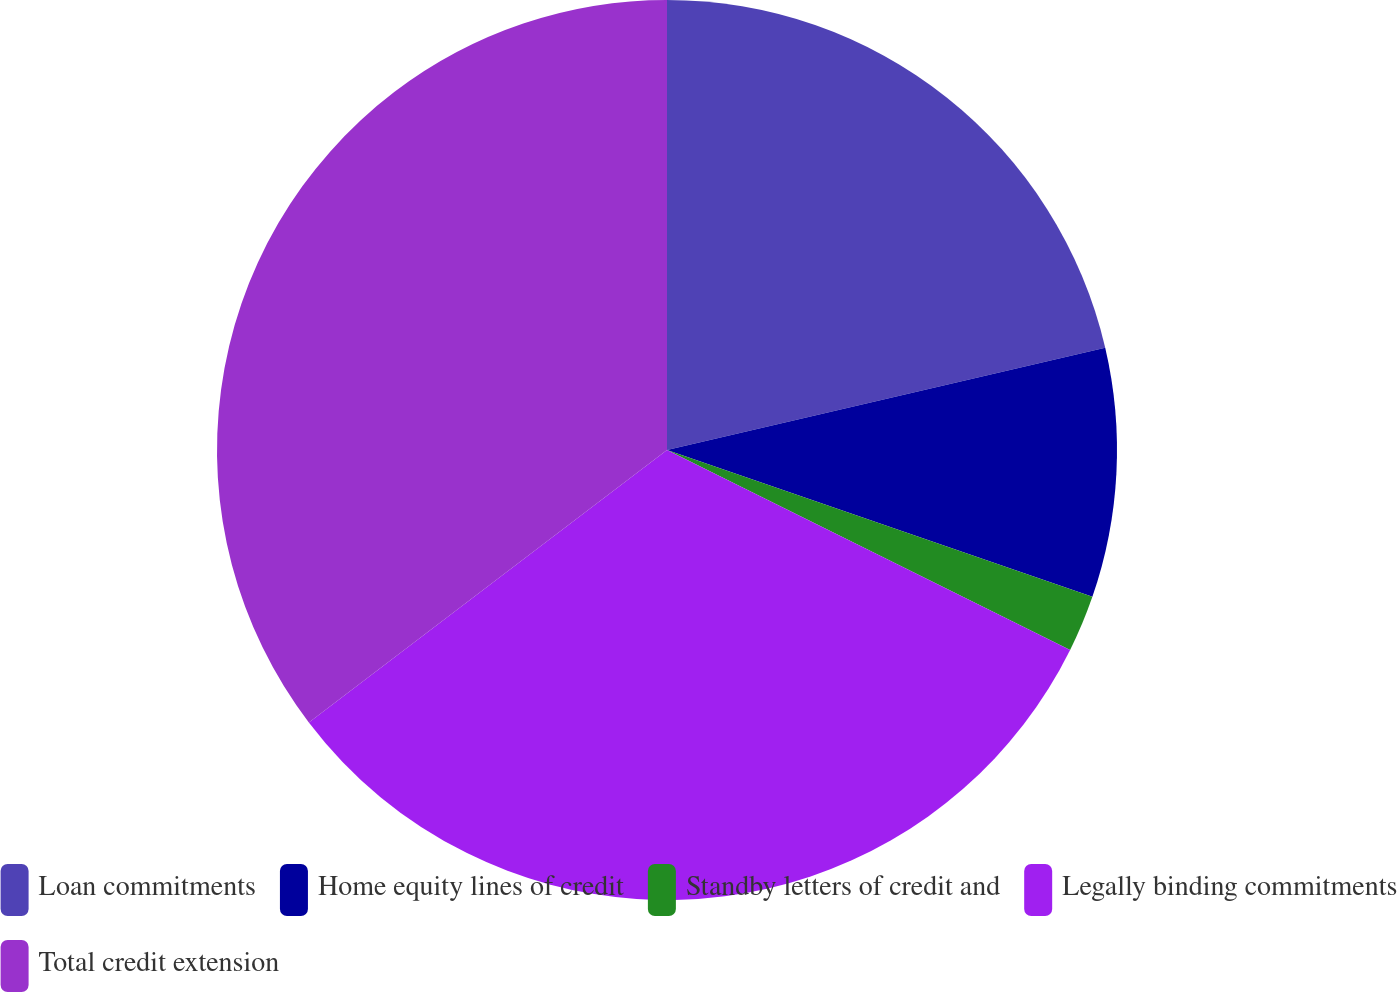Convert chart. <chart><loc_0><loc_0><loc_500><loc_500><pie_chart><fcel>Loan commitments<fcel>Home equity lines of credit<fcel>Standby letters of credit and<fcel>Legally binding commitments<fcel>Total credit extension<nl><fcel>21.35%<fcel>8.94%<fcel>2.04%<fcel>32.32%<fcel>35.35%<nl></chart> 